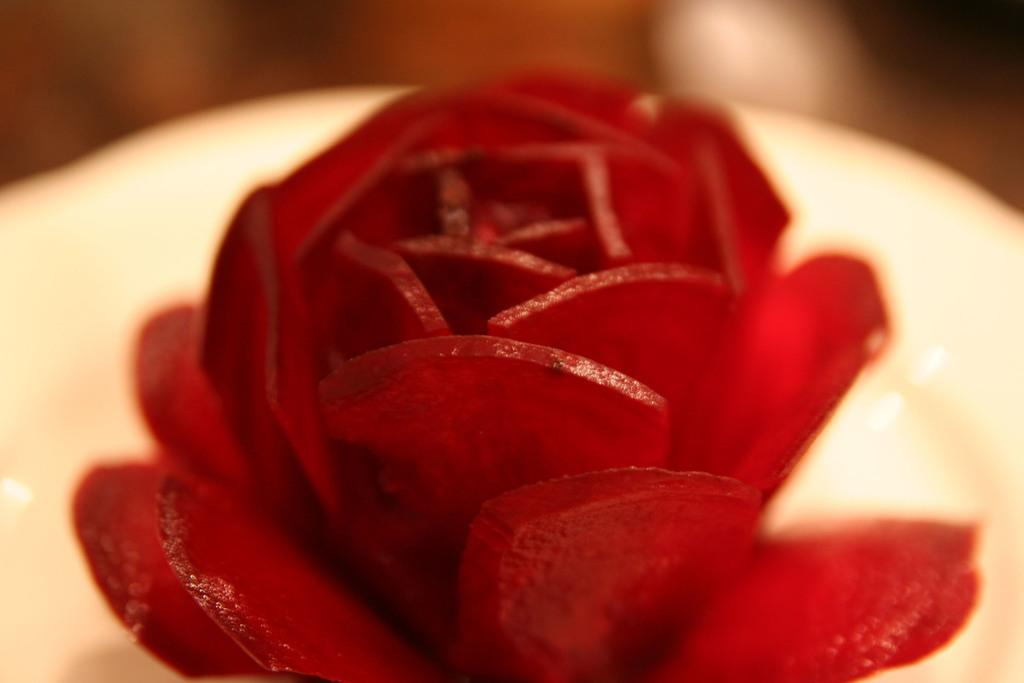What is the main subject of the image? The main subject of the image is a beetroot. How is the beetroot presented in the image? The beetroot is sliced into the shape of a flower. Can you describe the background of the image? The background of the image is blurry, and the colors are cream and brown. What type of note is being played in the background of the image? There is no note or music being played in the image; it features a sliced beetroot with a blurry background. 